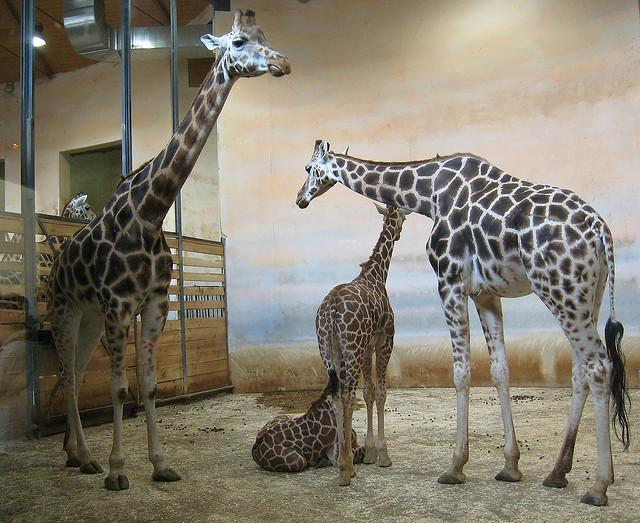What kind of venue is this?

Choices:
A) giraffe barn
B) zoo
C) wilderness
D) farm giraffe barn 